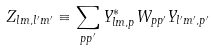Convert formula to latex. <formula><loc_0><loc_0><loc_500><loc_500>Z _ { l m , l ^ { \prime } m ^ { \prime } } \equiv \sum _ { p p ^ { \prime } } Y _ { l m , p } ^ { * } W _ { p p ^ { \prime } } Y _ { l ^ { \prime } m ^ { \prime } , p ^ { \prime } }</formula> 